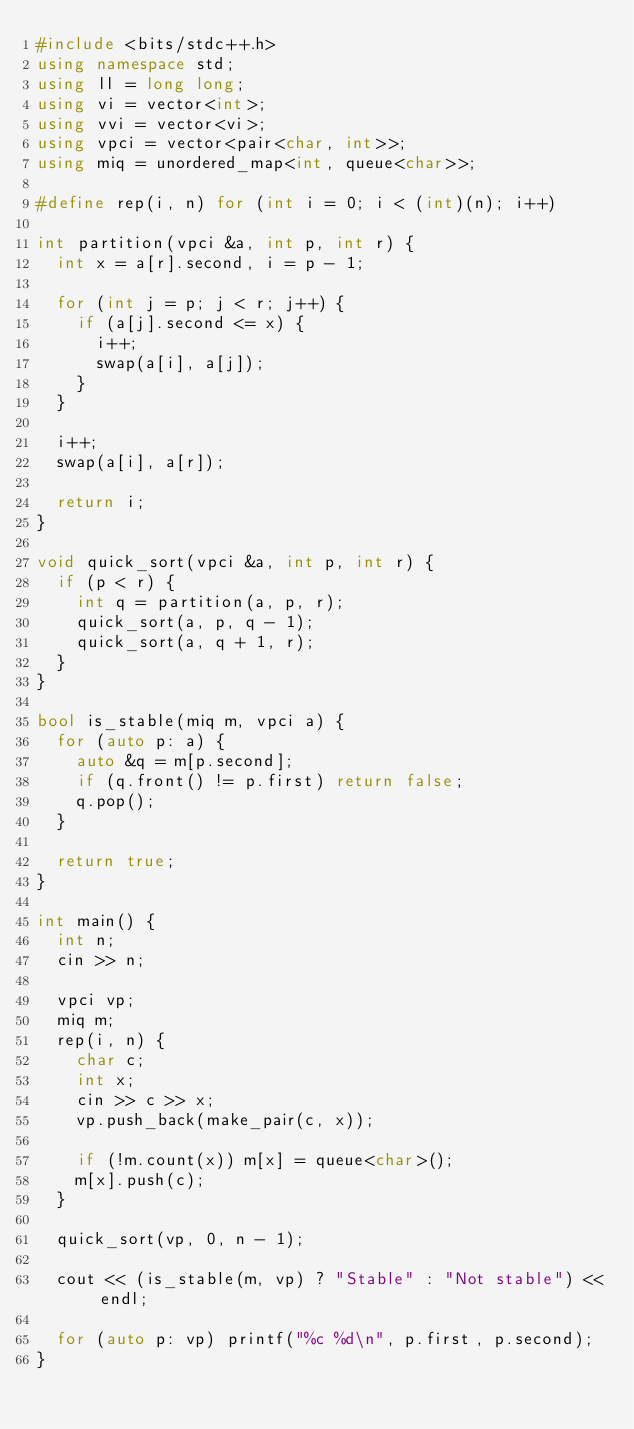Convert code to text. <code><loc_0><loc_0><loc_500><loc_500><_C++_>#include <bits/stdc++.h>
using namespace std;
using ll = long long;
using vi = vector<int>;
using vvi = vector<vi>;
using vpci = vector<pair<char, int>>;
using miq = unordered_map<int, queue<char>>;

#define rep(i, n) for (int i = 0; i < (int)(n); i++)

int partition(vpci &a, int p, int r) {
  int x = a[r].second, i = p - 1;
  
  for (int j = p; j < r; j++) {
    if (a[j].second <= x) {
      i++;
      swap(a[i], a[j]);
    }
  }
  
  i++;
  swap(a[i], a[r]);

  return i;
}

void quick_sort(vpci &a, int p, int r) {
  if (p < r) {
    int q = partition(a, p, r);
    quick_sort(a, p, q - 1);
    quick_sort(a, q + 1, r);
  }
}

bool is_stable(miq m, vpci a) {
  for (auto p: a) {
    auto &q = m[p.second];
    if (q.front() != p.first) return false;
    q.pop();
  }

  return true;
}

int main() {
  int n;
  cin >> n;
  
  vpci vp;
  miq m;
  rep(i, n) {
    char c;
    int x;
    cin >> c >> x;
    vp.push_back(make_pair(c, x));

    if (!m.count(x)) m[x] = queue<char>();
    m[x].push(c);
  }

  quick_sort(vp, 0, n - 1);
  
  cout << (is_stable(m, vp) ? "Stable" : "Not stable") << endl; 

  for (auto p: vp) printf("%c %d\n", p.first, p.second);
}

</code> 